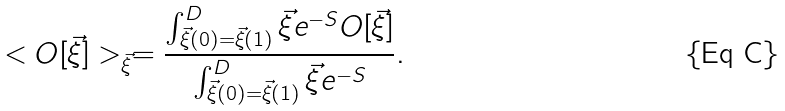<formula> <loc_0><loc_0><loc_500><loc_500>< O [ \vec { \xi } ] > _ { \vec { \xi } } = \frac { \int _ { \vec { \xi } ( 0 ) = \vec { \xi } ( 1 ) } ^ { D } \vec { \xi } e ^ { - S } O [ \vec { \xi } ] } { \int _ { \vec { \xi } ( 0 ) = \vec { \xi } ( 1 ) } ^ { D } \vec { \xi } e ^ { - S } } .</formula> 